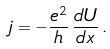Convert formula to latex. <formula><loc_0><loc_0><loc_500><loc_500>j = - \frac { e ^ { 2 } } { h } \, \frac { d U } { d x } \, .</formula> 